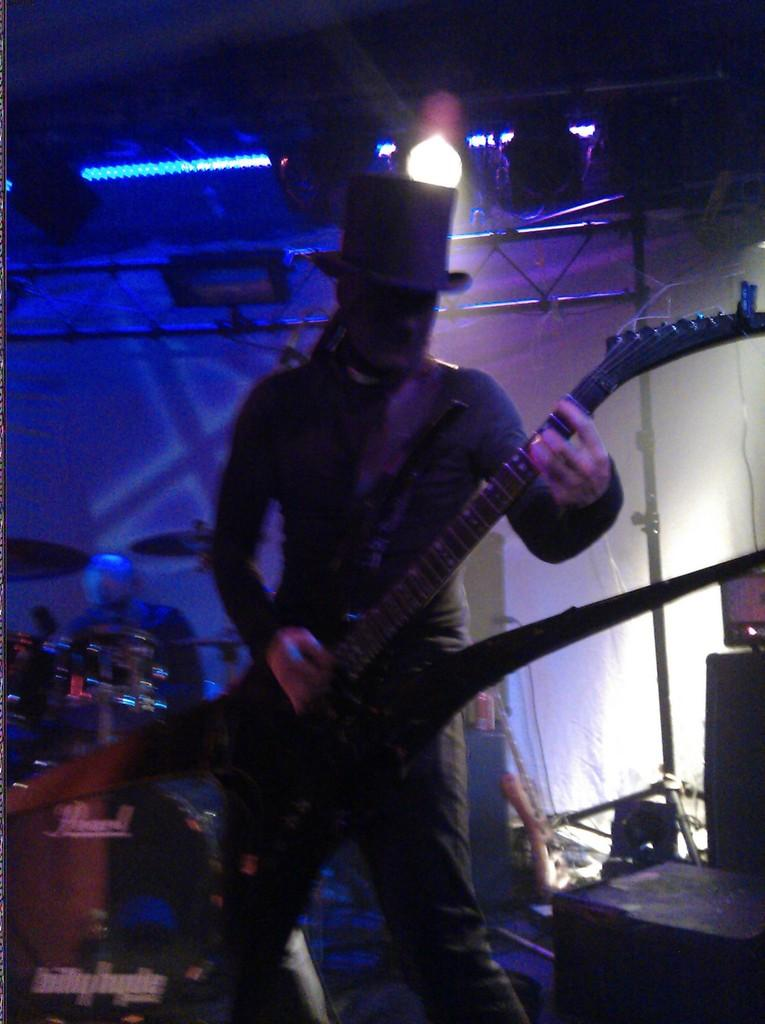Who is present in the image? There is a person in the image. What is the person wearing on their head? The person is wearing a hat. What object is the person holding? The person is holding a mobile. What type of musical instrument can be seen in the background of the image? There is a drum set in the background of the image. What can be seen providing illumination in the background of the image? There is a light in the background of the image. What type of boat is visible in the image? There is no boat present in the image. What type of medical equipment can be seen in the image? There is no medical equipment or hospital setting present in the image. 